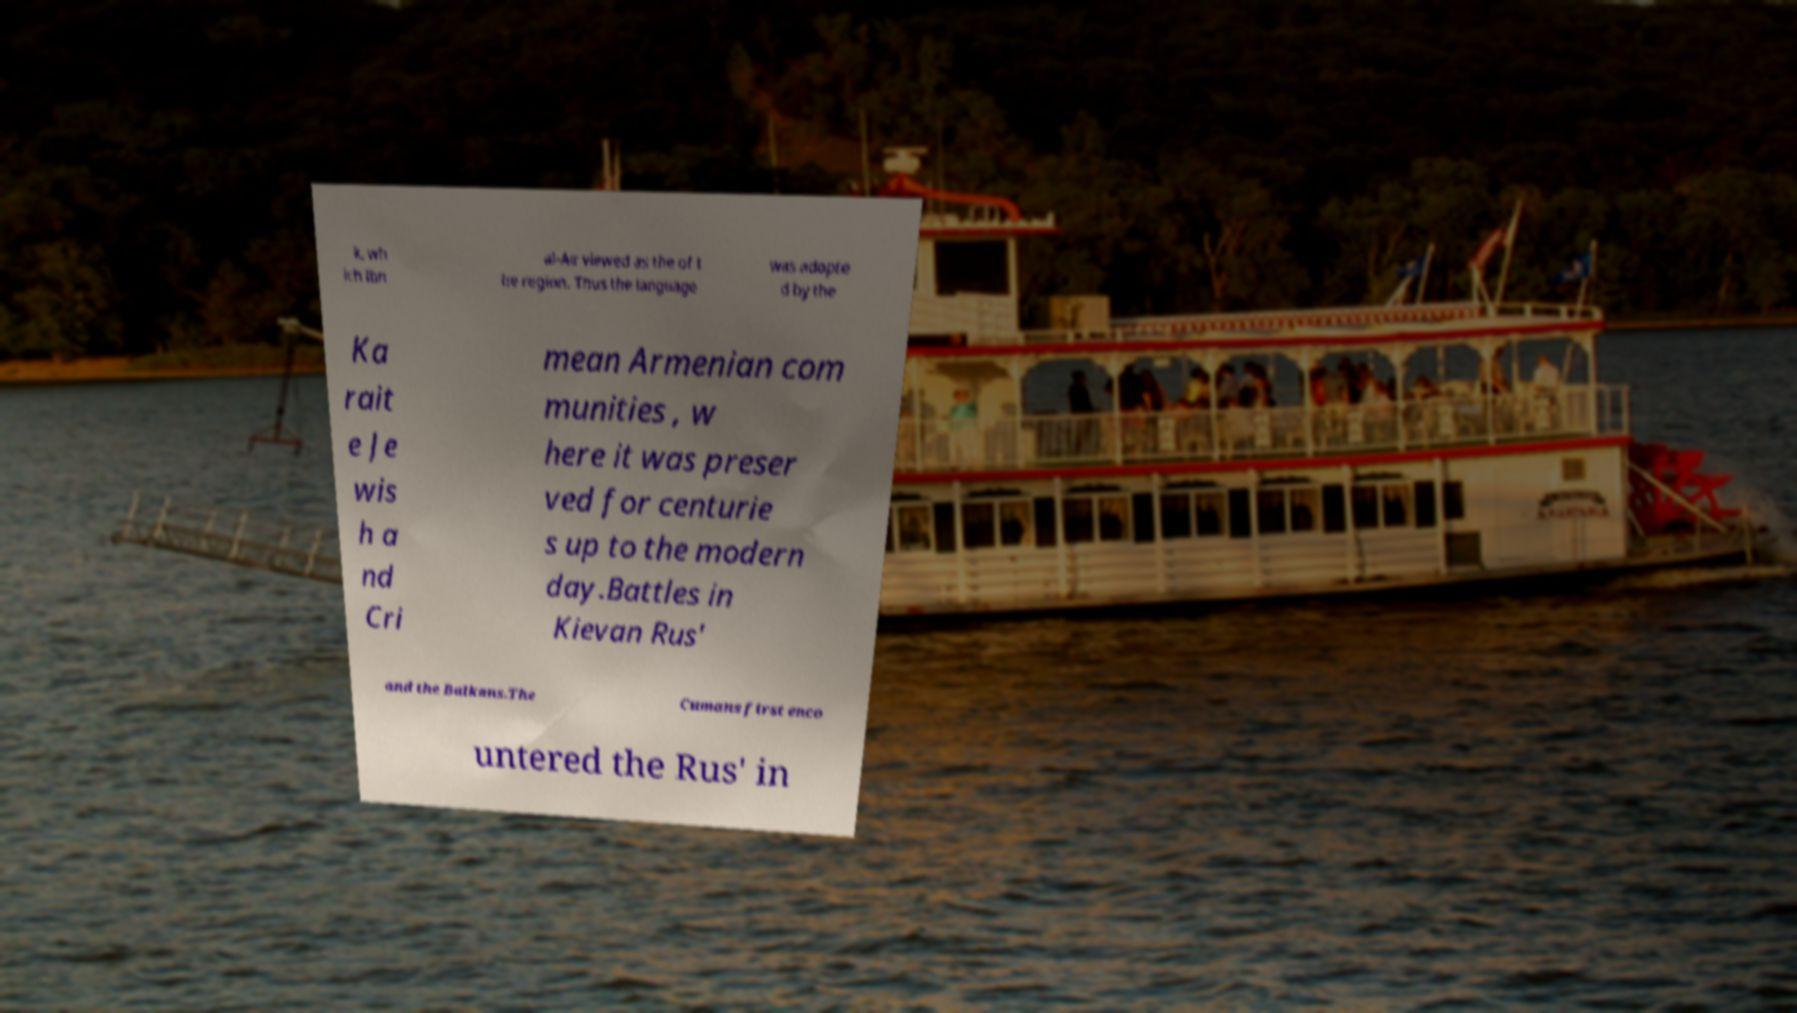There's text embedded in this image that I need extracted. Can you transcribe it verbatim? k, wh ich Ibn al-Air viewed as the of t he region. Thus the language was adopte d by the Ka rait e Je wis h a nd Cri mean Armenian com munities , w here it was preser ved for centurie s up to the modern day.Battles in Kievan Rus' and the Balkans.The Cumans first enco untered the Rus' in 